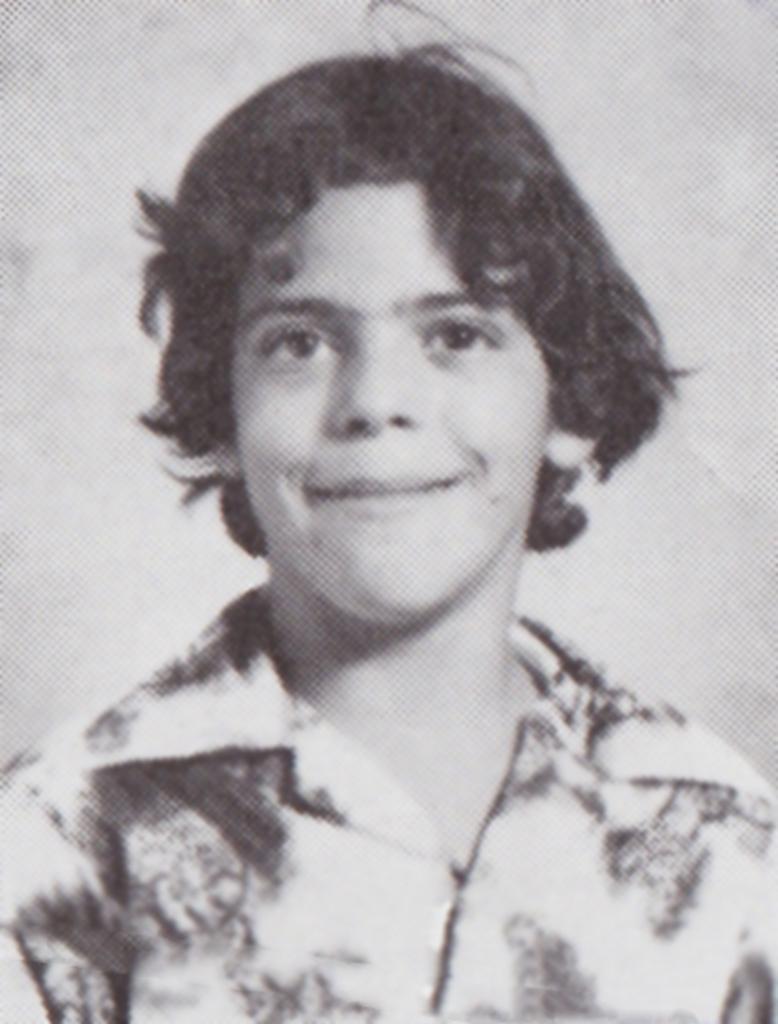Could you give a brief overview of what you see in this image? This is a black and white image, there is a man, he is wearing a shirt, the background of the image is white in color. 